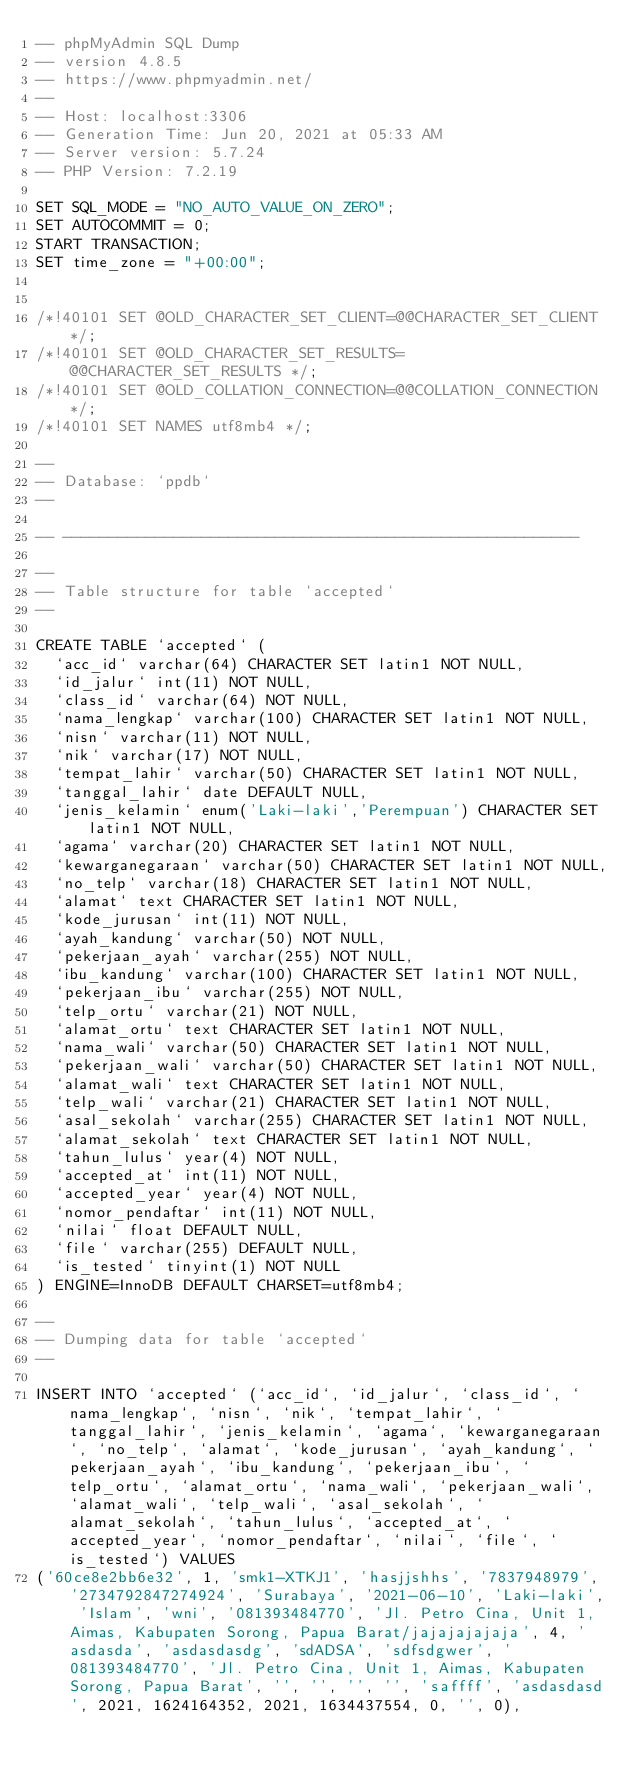<code> <loc_0><loc_0><loc_500><loc_500><_SQL_>-- phpMyAdmin SQL Dump
-- version 4.8.5
-- https://www.phpmyadmin.net/
--
-- Host: localhost:3306
-- Generation Time: Jun 20, 2021 at 05:33 AM
-- Server version: 5.7.24
-- PHP Version: 7.2.19

SET SQL_MODE = "NO_AUTO_VALUE_ON_ZERO";
SET AUTOCOMMIT = 0;
START TRANSACTION;
SET time_zone = "+00:00";


/*!40101 SET @OLD_CHARACTER_SET_CLIENT=@@CHARACTER_SET_CLIENT */;
/*!40101 SET @OLD_CHARACTER_SET_RESULTS=@@CHARACTER_SET_RESULTS */;
/*!40101 SET @OLD_COLLATION_CONNECTION=@@COLLATION_CONNECTION */;
/*!40101 SET NAMES utf8mb4 */;

--
-- Database: `ppdb`
--

-- --------------------------------------------------------

--
-- Table structure for table `accepted`
--

CREATE TABLE `accepted` (
  `acc_id` varchar(64) CHARACTER SET latin1 NOT NULL,
  `id_jalur` int(11) NOT NULL,
  `class_id` varchar(64) NOT NULL,
  `nama_lengkap` varchar(100) CHARACTER SET latin1 NOT NULL,
  `nisn` varchar(11) NOT NULL,
  `nik` varchar(17) NOT NULL,
  `tempat_lahir` varchar(50) CHARACTER SET latin1 NOT NULL,
  `tanggal_lahir` date DEFAULT NULL,
  `jenis_kelamin` enum('Laki-laki','Perempuan') CHARACTER SET latin1 NOT NULL,
  `agama` varchar(20) CHARACTER SET latin1 NOT NULL,
  `kewarganegaraan` varchar(50) CHARACTER SET latin1 NOT NULL,
  `no_telp` varchar(18) CHARACTER SET latin1 NOT NULL,
  `alamat` text CHARACTER SET latin1 NOT NULL,
  `kode_jurusan` int(11) NOT NULL,
  `ayah_kandung` varchar(50) NOT NULL,
  `pekerjaan_ayah` varchar(255) NOT NULL,
  `ibu_kandung` varchar(100) CHARACTER SET latin1 NOT NULL,
  `pekerjaan_ibu` varchar(255) NOT NULL,
  `telp_ortu` varchar(21) NOT NULL,
  `alamat_ortu` text CHARACTER SET latin1 NOT NULL,
  `nama_wali` varchar(50) CHARACTER SET latin1 NOT NULL,
  `pekerjaan_wali` varchar(50) CHARACTER SET latin1 NOT NULL,
  `alamat_wali` text CHARACTER SET latin1 NOT NULL,
  `telp_wali` varchar(21) CHARACTER SET latin1 NOT NULL,
  `asal_sekolah` varchar(255) CHARACTER SET latin1 NOT NULL,
  `alamat_sekolah` text CHARACTER SET latin1 NOT NULL,
  `tahun_lulus` year(4) NOT NULL,
  `accepted_at` int(11) NOT NULL,
  `accepted_year` year(4) NOT NULL,
  `nomor_pendaftar` int(11) NOT NULL,
  `nilai` float DEFAULT NULL,
  `file` varchar(255) DEFAULT NULL,
  `is_tested` tinyint(1) NOT NULL
) ENGINE=InnoDB DEFAULT CHARSET=utf8mb4;

--
-- Dumping data for table `accepted`
--

INSERT INTO `accepted` (`acc_id`, `id_jalur`, `class_id`, `nama_lengkap`, `nisn`, `nik`, `tempat_lahir`, `tanggal_lahir`, `jenis_kelamin`, `agama`, `kewarganegaraan`, `no_telp`, `alamat`, `kode_jurusan`, `ayah_kandung`, `pekerjaan_ayah`, `ibu_kandung`, `pekerjaan_ibu`, `telp_ortu`, `alamat_ortu`, `nama_wali`, `pekerjaan_wali`, `alamat_wali`, `telp_wali`, `asal_sekolah`, `alamat_sekolah`, `tahun_lulus`, `accepted_at`, `accepted_year`, `nomor_pendaftar`, `nilai`, `file`, `is_tested`) VALUES
('60ce8e2bb6e32', 1, 'smk1-XTKJ1', 'hasjjshhs', '7837948979', '2734792847274924', 'Surabaya', '2021-06-10', 'Laki-laki', 'Islam', 'wni', '081393484770', 'Jl. Petro Cina, Unit 1, Aimas, Kabupaten Sorong, Papua Barat/jajajajajaja', 4, 'asdasda', 'asdasdasdg', 'sdADSA', 'sdfsdgwer', '081393484770', 'Jl. Petro Cina, Unit 1, Aimas, Kabupaten Sorong, Papua Barat', '', '', '', '', 'saffff', 'asdasdasd', 2021, 1624164352, 2021, 1634437554, 0, '', 0),</code> 